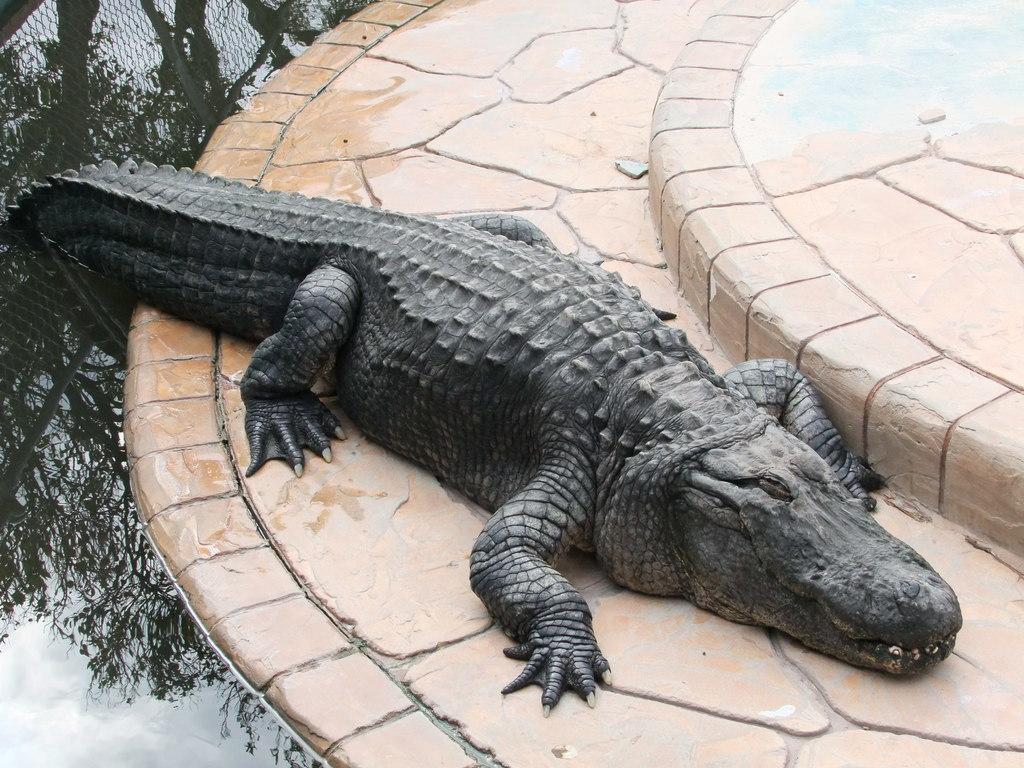Please provide a concise description of this image. In this image, we can see a crocodile. There is a pond on the left side of the image. 